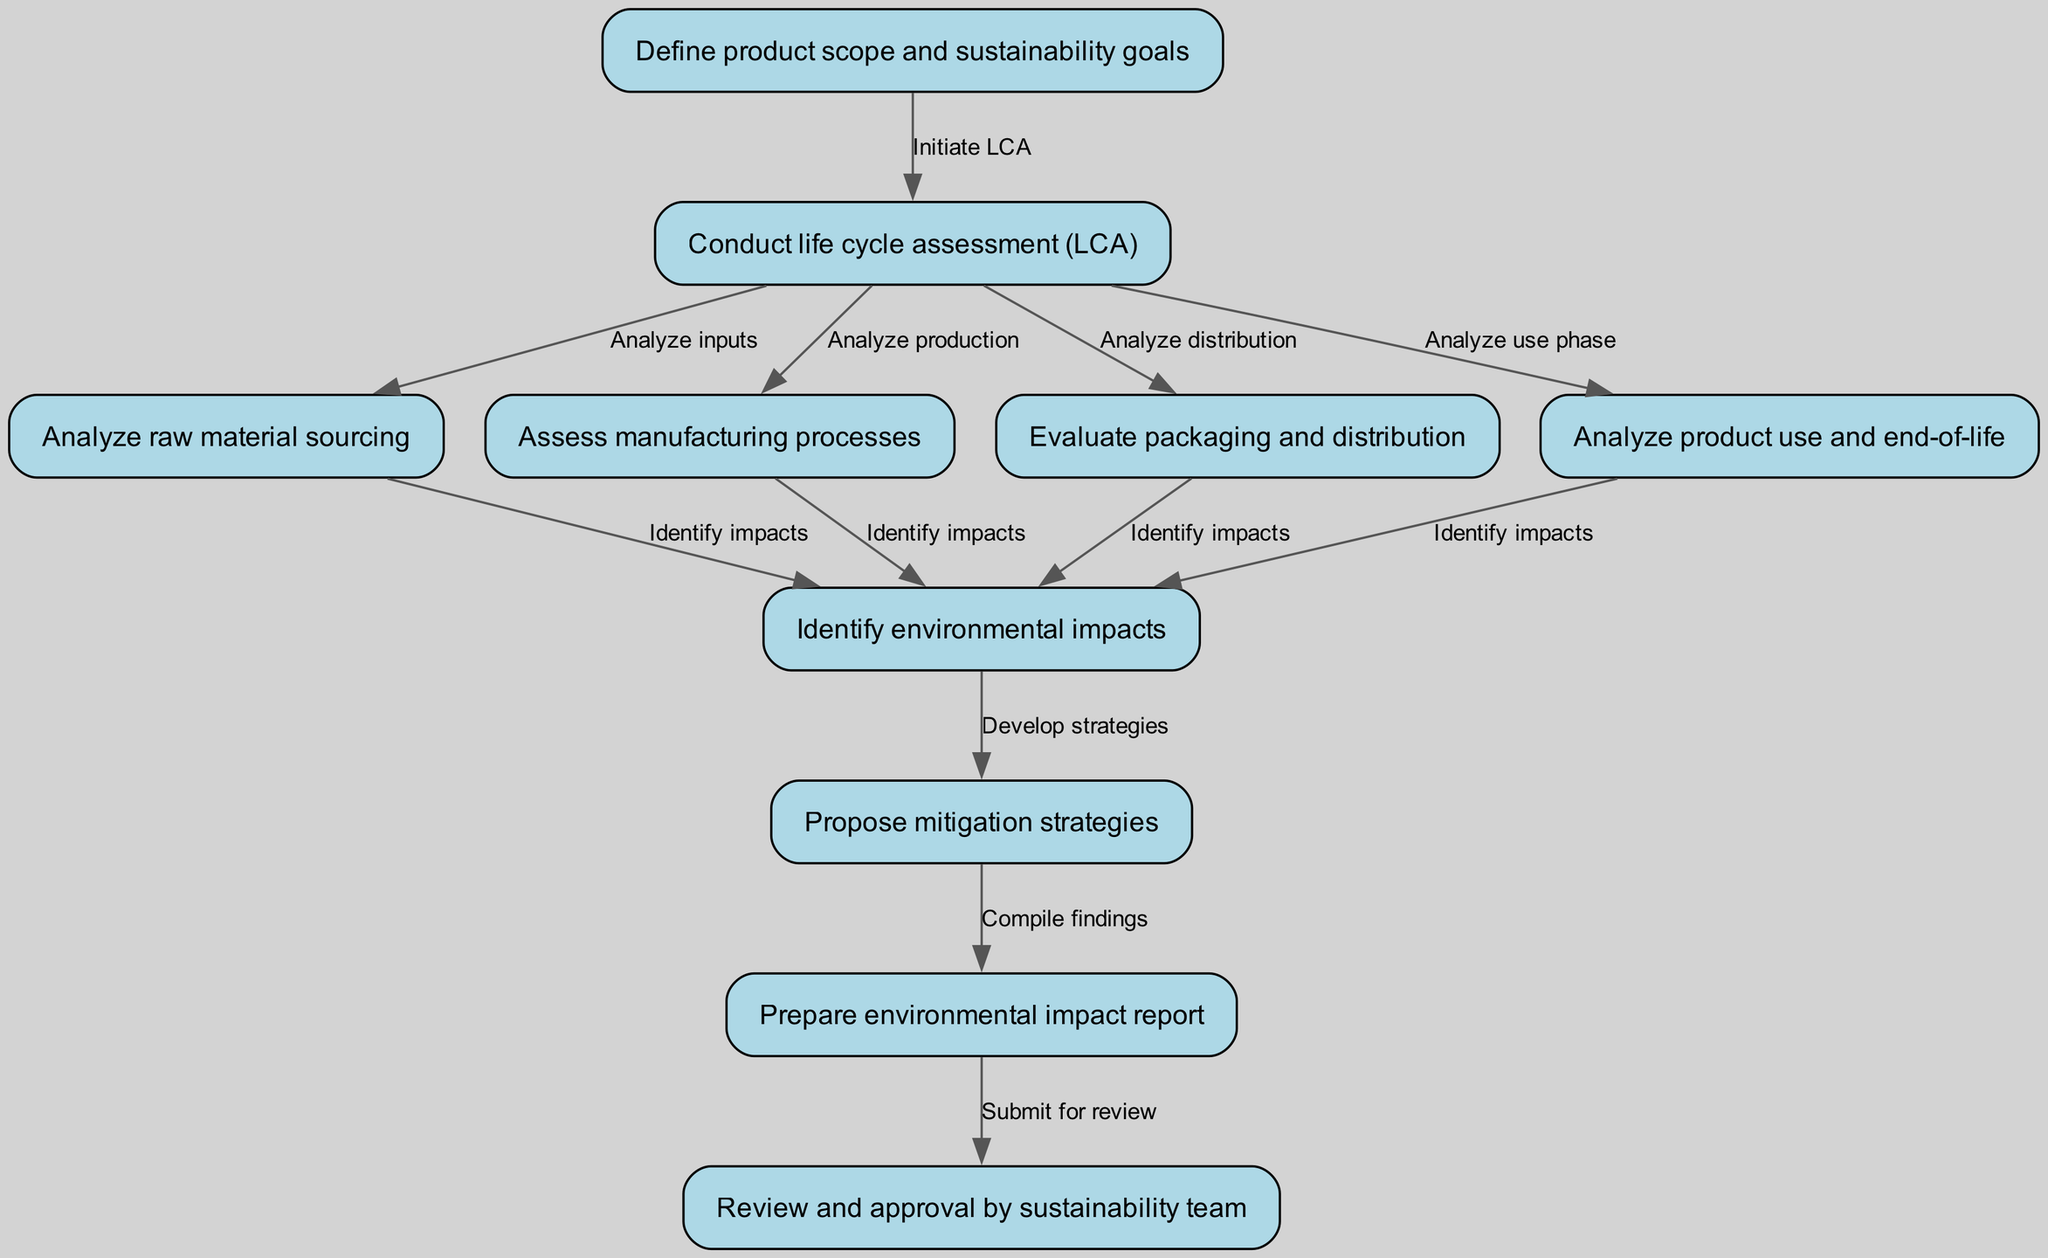What is the first step in the clinical pathway? The first step, as indicated in the diagram, is "Define product scope and sustainability goals". This is the initial node, labeled as node 1.
Answer: Define product scope and sustainability goals How many nodes are in the diagram? By counting the nodes listed in the provided data, there are a total of 10 nodes in the clinical pathway.
Answer: 10 Which node follows the life cycle assessment? After the node "Conduct life cycle assessment (LCA)" (node 2), the next steps include analyzing raw material sourcing, manufacturing processes, packaging and distribution, and product use and end-of-life. However, one specific node that immediately follows it does not exist; instead, it feeds into several analyses.
Answer: None What connects raw material sourcing to environmental impacts? The edge labeled "Identify impacts" connects the node "Analyze raw material sourcing" (node 3) to "Identify environmental impacts" (node 7), indicating that the analysis of raw materials contributes to understanding environmental impacts.
Answer: Identify impacts How many steps involve analyzing processes? There are 4 steps in the pathway that involve analyzing different processes: analyzing raw material sourcing, manufacturing processes, packaging and distribution, and product use. Because there is one node for each analysis, counting them gives a total of 4 steps.
Answer: 4 What is the last step of the clinical pathway? The final step in the clinical pathway, as depicted, is "Review and approval by sustainability team", which is the last node (node 10).
Answer: Review and approval by sustainability team What does node 8 indicate? Node 8 represents the stage where mitigation strategies are proposed based on the identified environmental impacts from earlier analyses. This is a crucial step in addressing the impacts outlined in node 7.
Answer: Propose mitigation strategies Which nodes analyze the distribution phase? The node that specifically analyzes the distribution phase is "Evaluate packaging and distribution" (node 5). This node connects directly to "Identify environmental impacts" (node 7).
Answer: Evaluate packaging and distribution How many edges lead to environmental impact identification? There are 4 edges leading to the node "Identify environmental impacts" (node 7) from various analysis nodes: raw material sourcing, manufacturing processes, packaging and distribution, and product use and end-of-life. This shows a comprehensive assessment of impacts from multiple stages of the product line's lifecycle.
Answer: 4 